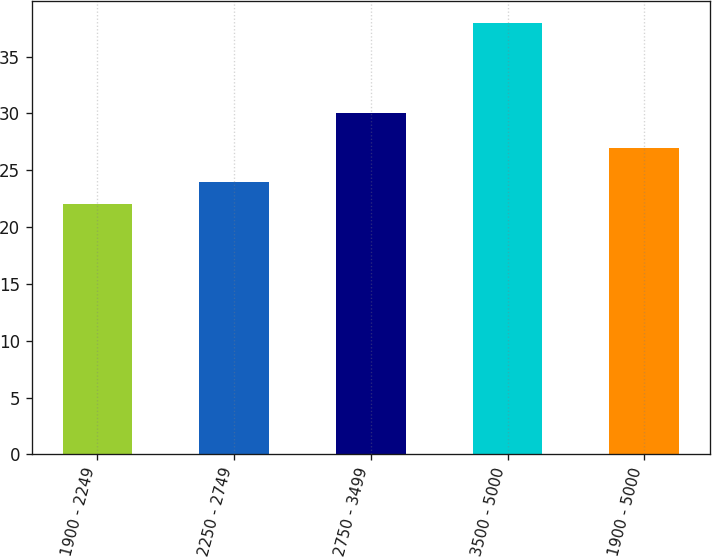Convert chart to OTSL. <chart><loc_0><loc_0><loc_500><loc_500><bar_chart><fcel>1900 - 2249<fcel>2250 - 2749<fcel>2750 - 3499<fcel>3500 - 5000<fcel>1900 - 5000<nl><fcel>22<fcel>24<fcel>30<fcel>38<fcel>27<nl></chart> 